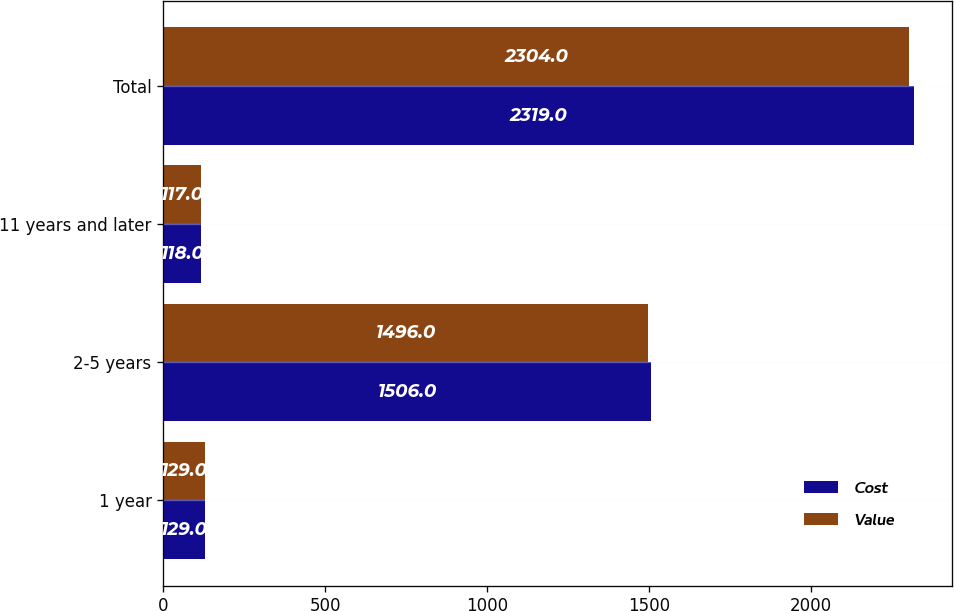<chart> <loc_0><loc_0><loc_500><loc_500><stacked_bar_chart><ecel><fcel>1 year<fcel>2-5 years<fcel>11 years and later<fcel>Total<nl><fcel>Cost<fcel>129<fcel>1506<fcel>118<fcel>2319<nl><fcel>Value<fcel>129<fcel>1496<fcel>117<fcel>2304<nl></chart> 